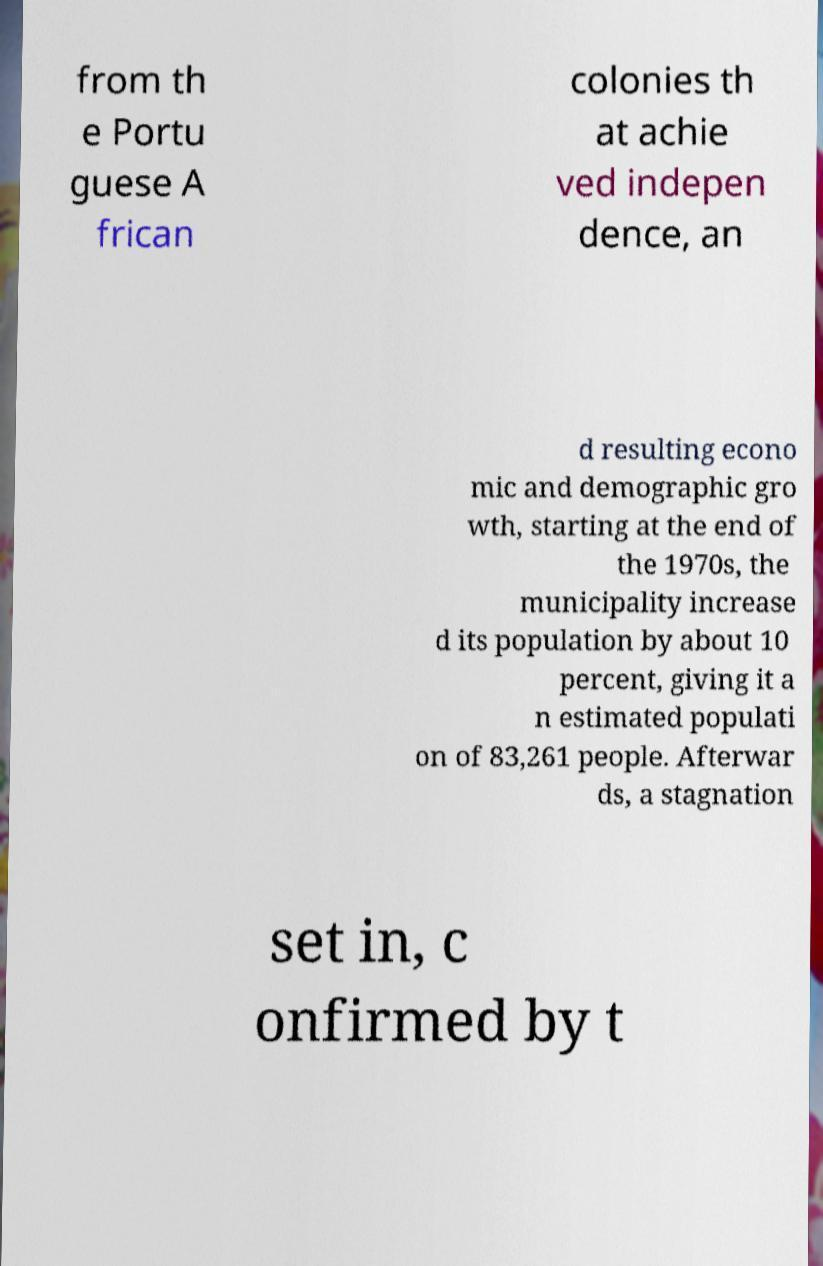Could you assist in decoding the text presented in this image and type it out clearly? from th e Portu guese A frican colonies th at achie ved indepen dence, an d resulting econo mic and demographic gro wth, starting at the end of the 1970s, the municipality increase d its population by about 10 percent, giving it a n estimated populati on of 83,261 people. Afterwar ds, a stagnation set in, c onfirmed by t 